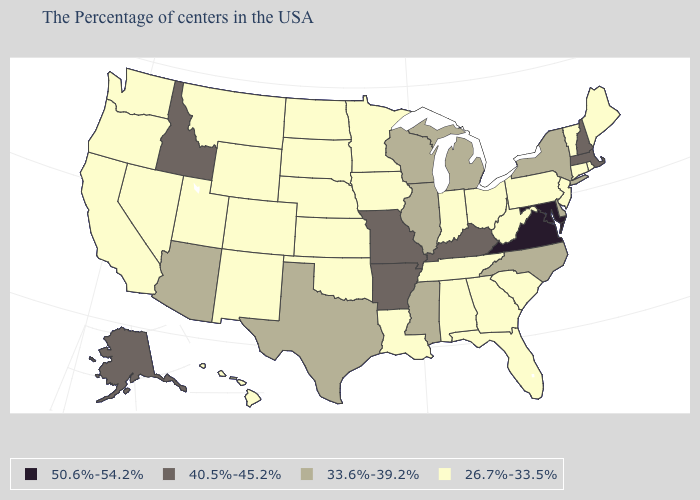Among the states that border Nevada , does Idaho have the lowest value?
Concise answer only. No. Which states hav the highest value in the South?
Concise answer only. Maryland, Virginia. What is the value of Michigan?
Be succinct. 33.6%-39.2%. What is the value of Vermont?
Keep it brief. 26.7%-33.5%. Does Mississippi have the same value as New York?
Quick response, please. Yes. Does Indiana have the lowest value in the MidWest?
Short answer required. Yes. Name the states that have a value in the range 26.7%-33.5%?
Answer briefly. Maine, Rhode Island, Vermont, Connecticut, New Jersey, Pennsylvania, South Carolina, West Virginia, Ohio, Florida, Georgia, Indiana, Alabama, Tennessee, Louisiana, Minnesota, Iowa, Kansas, Nebraska, Oklahoma, South Dakota, North Dakota, Wyoming, Colorado, New Mexico, Utah, Montana, Nevada, California, Washington, Oregon, Hawaii. What is the value of Delaware?
Give a very brief answer. 33.6%-39.2%. How many symbols are there in the legend?
Answer briefly. 4. Among the states that border Oklahoma , which have the highest value?
Answer briefly. Missouri, Arkansas. What is the value of Missouri?
Quick response, please. 40.5%-45.2%. What is the highest value in states that border Nevada?
Give a very brief answer. 40.5%-45.2%. Does South Dakota have a higher value than Alaska?
Concise answer only. No. Name the states that have a value in the range 50.6%-54.2%?
Write a very short answer. Maryland, Virginia. What is the lowest value in the South?
Keep it brief. 26.7%-33.5%. 